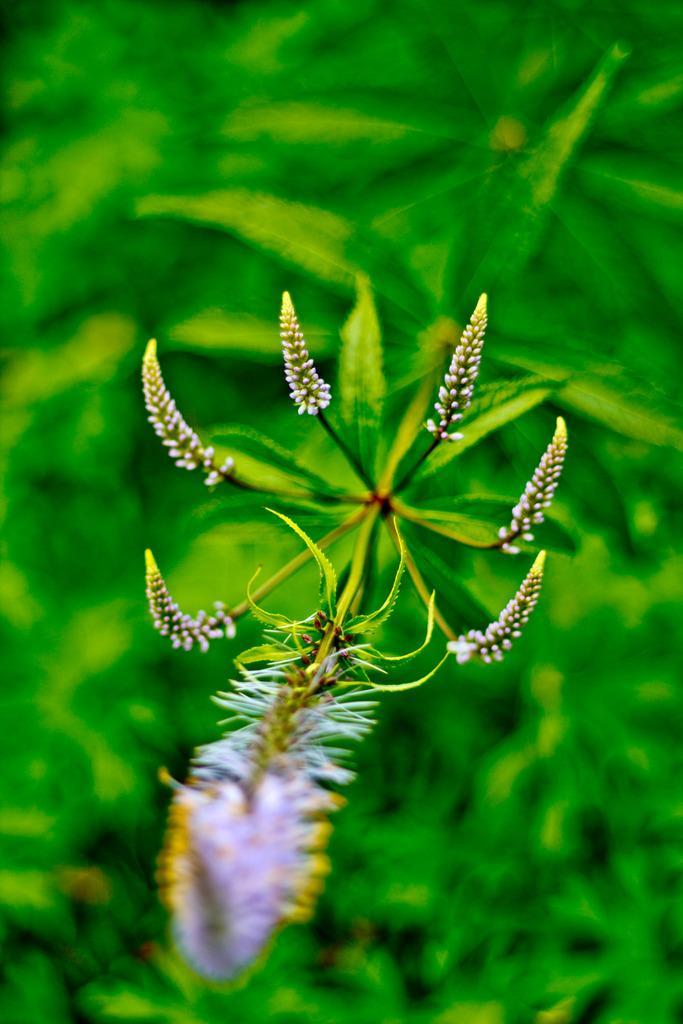Please provide a concise description of this image. As we can see in the image there are plants and flowers. 